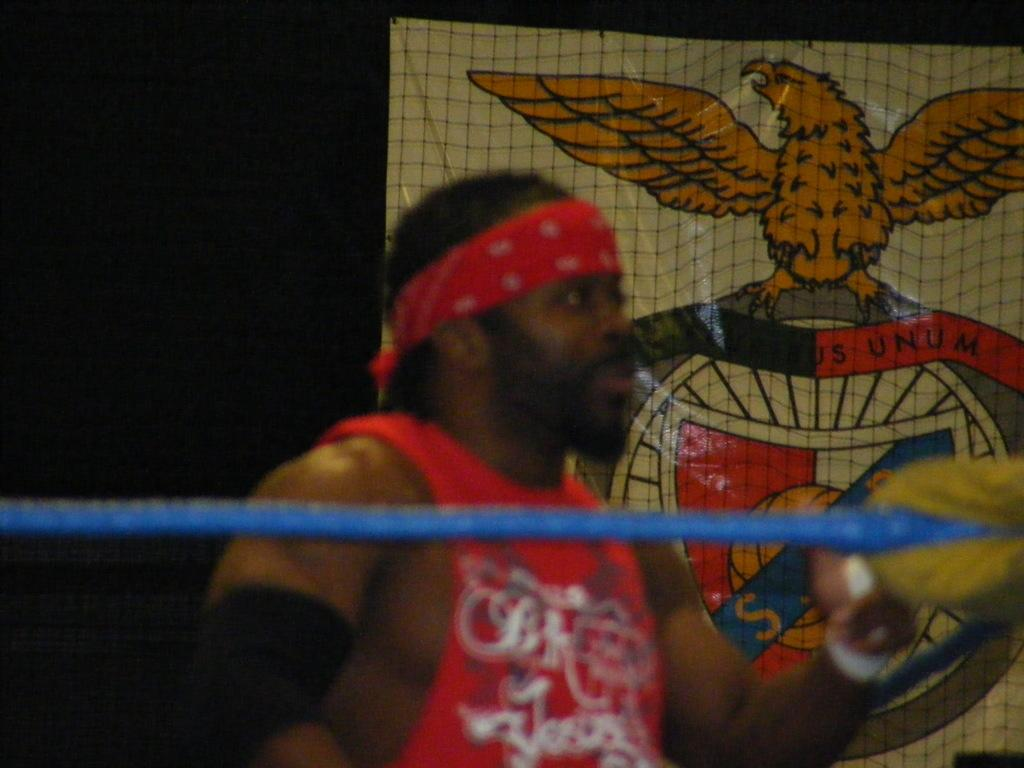Who is the main subject in the image? There is a man in the center of the image. What is in front of the man? There is a rope in front of the man. What can be seen in the background of the image? There is a poster in the background of the image. What type of theory is the man discussing with the cattle in the image? There are no cattle present in the image, and the man is not discussing any theories. 